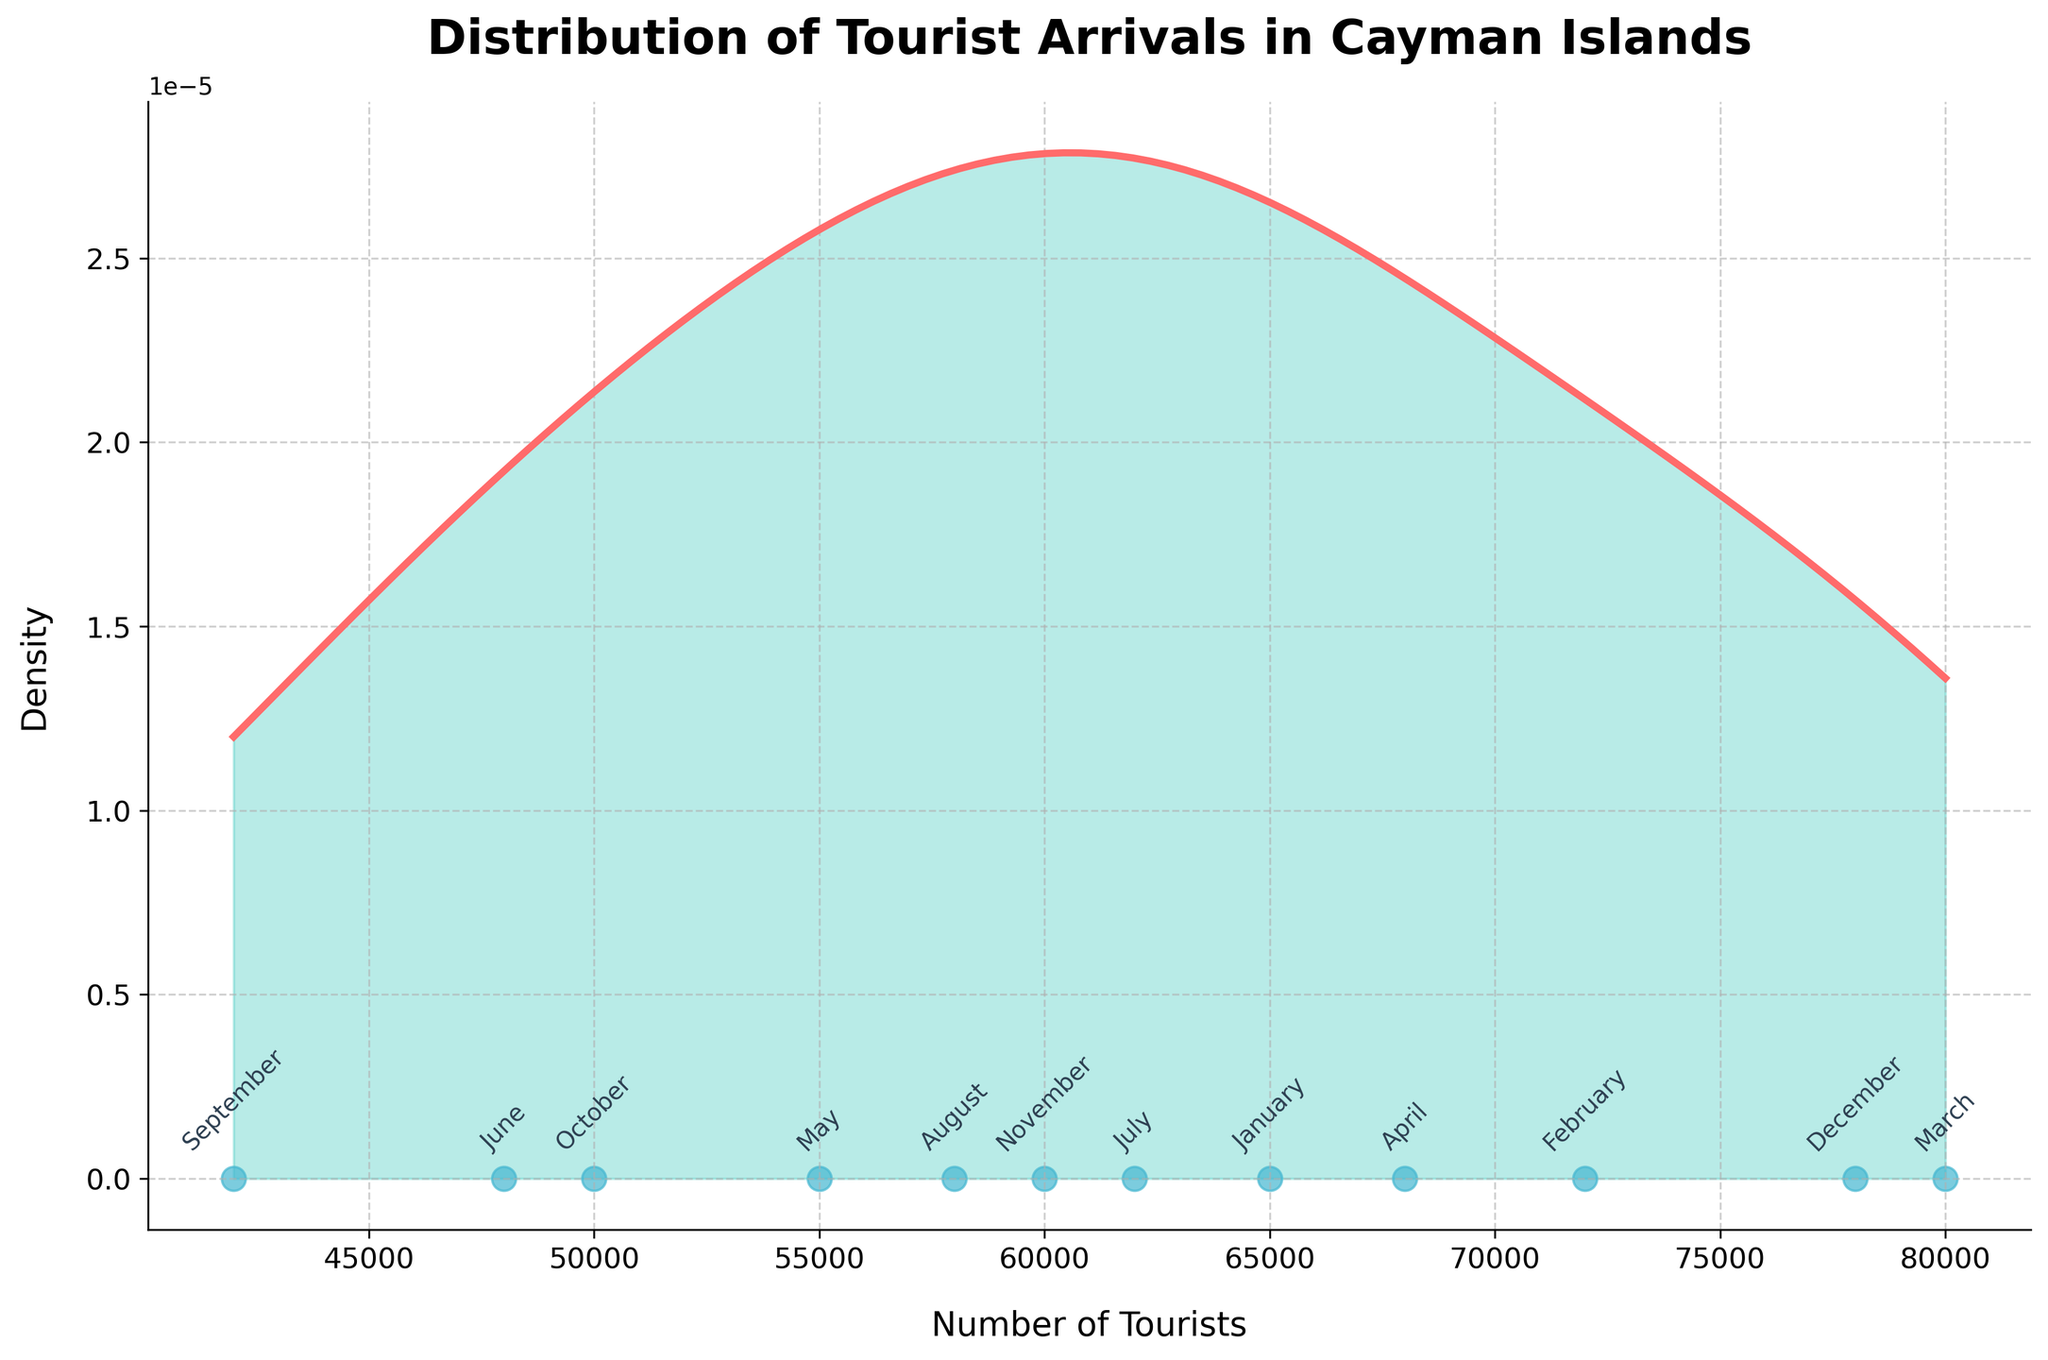What is the title of the plot? The title is usually placed at the top of the figure. By looking at the figure, you can see the title "Distribution of Tourist Arrivals in Cayman Islands."
Answer: Distribution of Tourist Arrivals in Cayman Islands How many data points are shown in the plot? Data points are represented by the scattered points on the density plot. By counting them, you will find there are 12 data points.
Answer: 12 Which month has the highest tourist arrivals? Look at the scatter plot points and find the highest value on the x-axis. The annotation will show the corresponding month, which is March.
Answer: March What can be observed about the tourist arrivals in September compared to other months? September's arrival is plotted on the x-axis at the lowest value. This indicates that September has the lowest tourist arrivals among other months.
Answer: It has the lowest arrivals Which months have tourist arrivals greater than 70,000? Observing the scatter points and their annotations, January, February, March, and December have arrivals greater than 70,000.
Answer: January, February, March, December What is the range of tourist arrivals in the plot? The range can be determined by looking at the minimum and maximum values on the x-axis. The smallest value is 42,000 (for September), and the highest value is 80,000 (for March). The range is 80,000 - 42,000.
Answer: 38,000 What can you say about the density of tourist arrivals around the value 60,000? By analyzing the density curve, the area around 60,000 can be observed. The density is relatively high around this value, indicating many months have tourist arrivals close to 60,000.
Answer: High density Describe the pattern of tourist arrivals throughout the year. By following the scatter plot from January to December, the general pattern shows higher tourist arrivals at the year's start and end, with a dip in the middle months, especially towards September.
Answer: Higher start and end, dip in middle Which months have tourist arrivals closest to the overall density peak? The peak of the density curve approximately corresponds to values around 55,000 to 65,000. May and October have arrivals close to these peak densities.
Answer: May and October Approximately, what proportion of months see tourist arrivals below 50,000? Observing the scatter plot, only June, September, and October have arrivals below 50,000. Since there are a total of 12 months, the proportion is approximately 3/12.
Answer: 1/4 